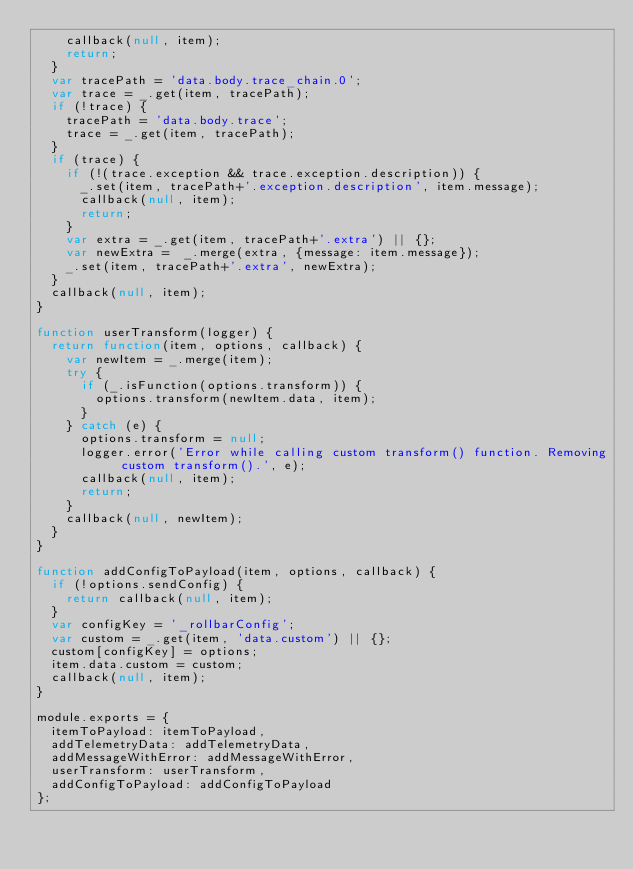<code> <loc_0><loc_0><loc_500><loc_500><_JavaScript_>    callback(null, item);
    return;
  }
  var tracePath = 'data.body.trace_chain.0';
  var trace = _.get(item, tracePath);
  if (!trace) {
    tracePath = 'data.body.trace';
    trace = _.get(item, tracePath);
  }
  if (trace) {
    if (!(trace.exception && trace.exception.description)) {
      _.set(item, tracePath+'.exception.description', item.message);
      callback(null, item);
      return;
    }
    var extra = _.get(item, tracePath+'.extra') || {};
    var newExtra =  _.merge(extra, {message: item.message});
    _.set(item, tracePath+'.extra', newExtra);
  }
  callback(null, item);
}

function userTransform(logger) {
  return function(item, options, callback) {
    var newItem = _.merge(item);
    try {
      if (_.isFunction(options.transform)) {
        options.transform(newItem.data, item);
      }
    } catch (e) {
      options.transform = null;
      logger.error('Error while calling custom transform() function. Removing custom transform().', e);
      callback(null, item);
      return;
    }
    callback(null, newItem);
  }
}

function addConfigToPayload(item, options, callback) {
  if (!options.sendConfig) {
    return callback(null, item);
  }
  var configKey = '_rollbarConfig';
  var custom = _.get(item, 'data.custom') || {};
  custom[configKey] = options;
  item.data.custom = custom;
  callback(null, item);
}

module.exports = {
  itemToPayload: itemToPayload,
  addTelemetryData: addTelemetryData,
  addMessageWithError: addMessageWithError,
  userTransform: userTransform,
  addConfigToPayload: addConfigToPayload
};
</code> 